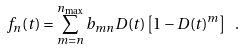Convert formula to latex. <formula><loc_0><loc_0><loc_500><loc_500>f _ { n } ( t ) = \sum _ { m = n } ^ { n _ { \max } } b _ { m n } D ( t ) \left [ 1 - D ( t ) ^ { m } \right ] \ .</formula> 